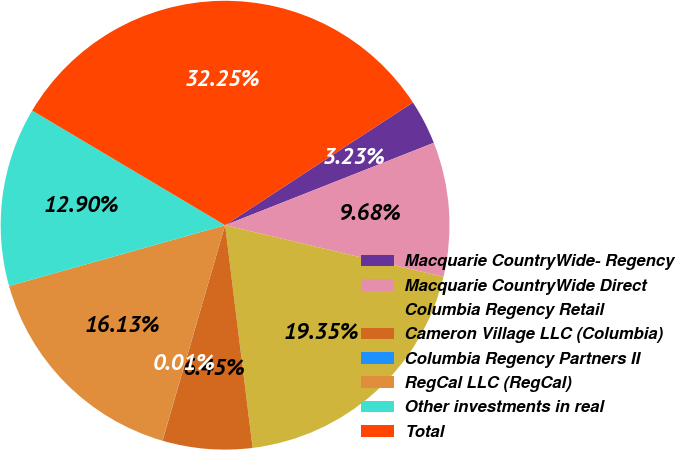Convert chart. <chart><loc_0><loc_0><loc_500><loc_500><pie_chart><fcel>Macquarie CountryWide- Regency<fcel>Macquarie CountryWide Direct<fcel>Columbia Regency Retail<fcel>Cameron Village LLC (Columbia)<fcel>Columbia Regency Partners II<fcel>RegCal LLC (RegCal)<fcel>Other investments in real<fcel>Total<nl><fcel>3.23%<fcel>9.68%<fcel>19.35%<fcel>6.45%<fcel>0.01%<fcel>16.13%<fcel>12.9%<fcel>32.25%<nl></chart> 